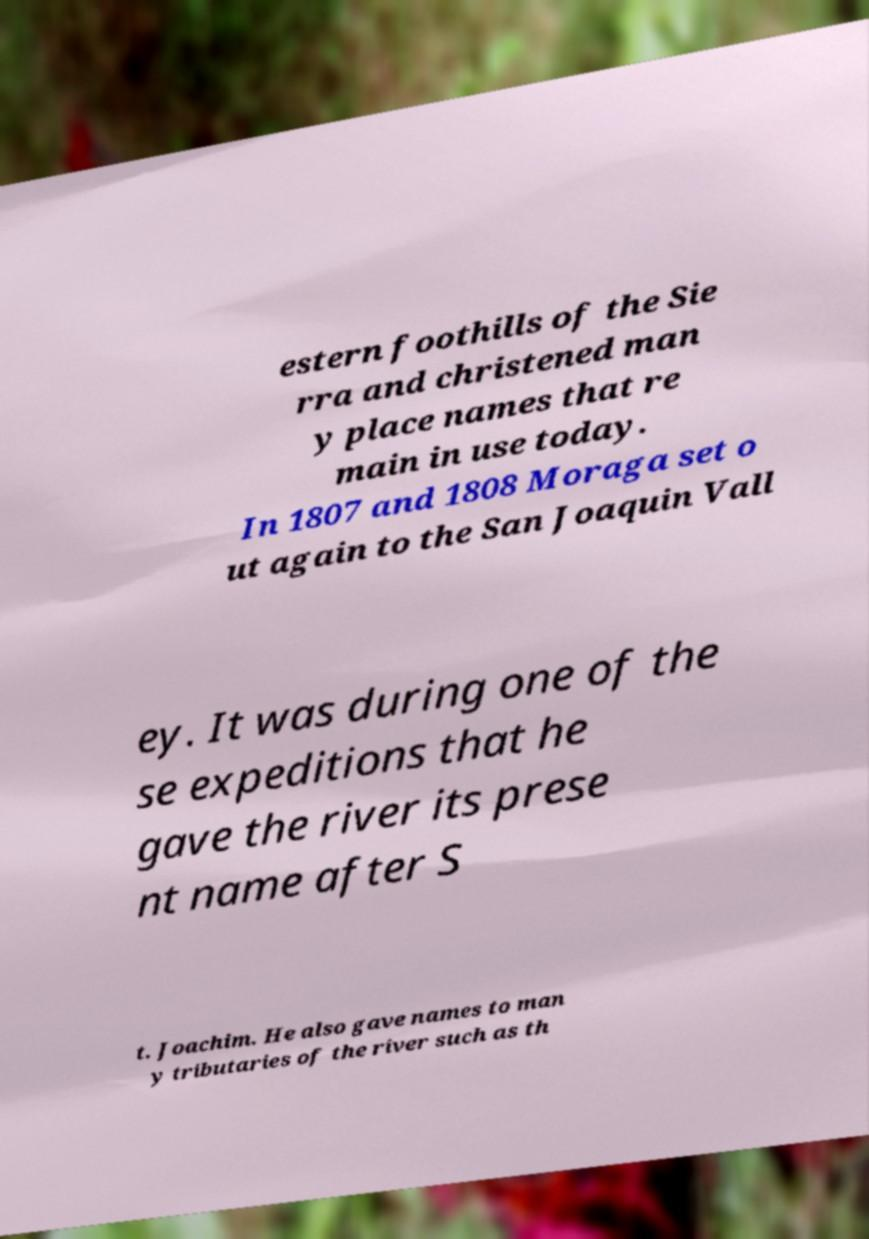There's text embedded in this image that I need extracted. Can you transcribe it verbatim? estern foothills of the Sie rra and christened man y place names that re main in use today. In 1807 and 1808 Moraga set o ut again to the San Joaquin Vall ey. It was during one of the se expeditions that he gave the river its prese nt name after S t. Joachim. He also gave names to man y tributaries of the river such as th 